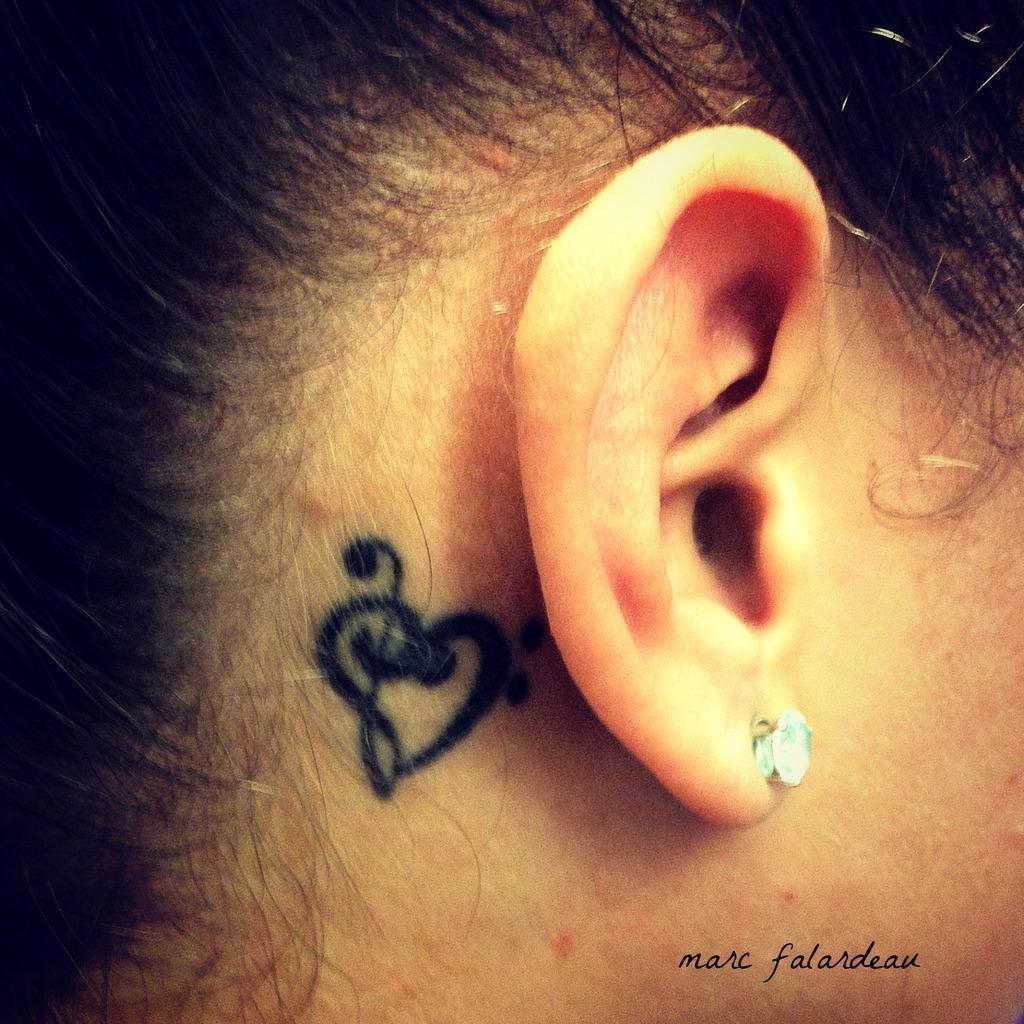Can you describe this image briefly? In this image there is one person's ear is visible and she is wearing an earring, and beside the ear there is a tattoo. At the bottom of the image there is text. 